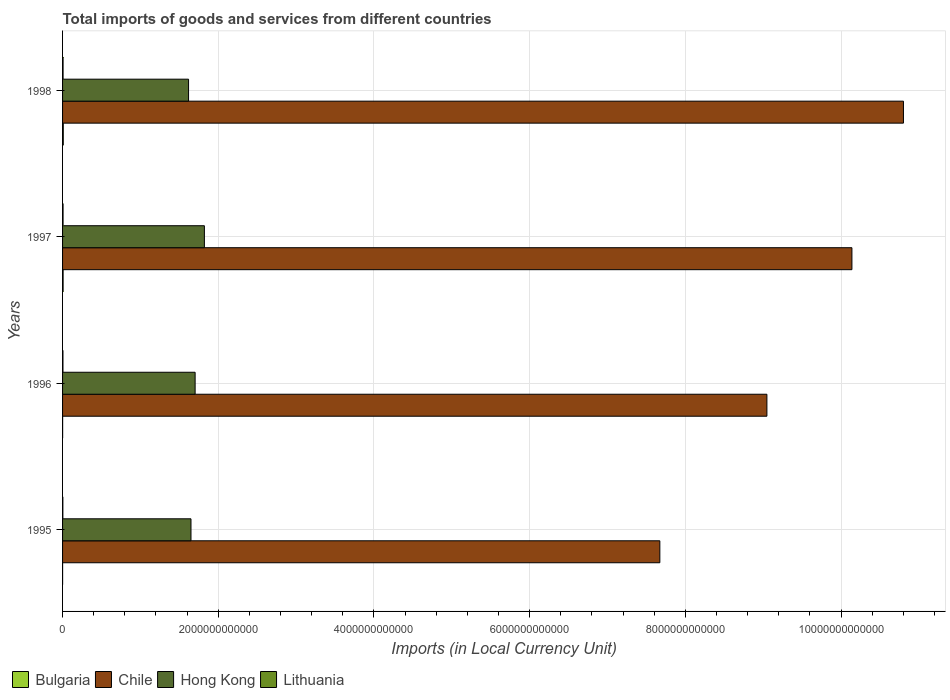How many groups of bars are there?
Offer a terse response. 4. Are the number of bars on each tick of the Y-axis equal?
Your response must be concise. Yes. What is the label of the 1st group of bars from the top?
Your answer should be very brief. 1998. What is the Amount of goods and services imports in Lithuania in 1997?
Offer a terse response. 6.45e+09. Across all years, what is the maximum Amount of goods and services imports in Lithuania?
Ensure brevity in your answer.  6.58e+09. Across all years, what is the minimum Amount of goods and services imports in Chile?
Ensure brevity in your answer.  7.67e+12. In which year was the Amount of goods and services imports in Bulgaria minimum?
Provide a succinct answer. 1995. What is the total Amount of goods and services imports in Lithuania in the graph?
Provide a succinct answer. 2.17e+1. What is the difference between the Amount of goods and services imports in Lithuania in 1995 and that in 1998?
Give a very brief answer. -2.87e+09. What is the difference between the Amount of goods and services imports in Bulgaria in 1997 and the Amount of goods and services imports in Hong Kong in 1998?
Offer a very short reply. -1.61e+12. What is the average Amount of goods and services imports in Hong Kong per year?
Make the answer very short. 1.70e+12. In the year 1997, what is the difference between the Amount of goods and services imports in Bulgaria and Amount of goods and services imports in Lithuania?
Keep it short and to the point. 5.67e+08. What is the ratio of the Amount of goods and services imports in Chile in 1995 to that in 1996?
Provide a short and direct response. 0.85. Is the Amount of goods and services imports in Chile in 1995 less than that in 1998?
Offer a terse response. Yes. What is the difference between the highest and the second highest Amount of goods and services imports in Hong Kong?
Provide a succinct answer. 1.19e+11. What is the difference between the highest and the lowest Amount of goods and services imports in Chile?
Your answer should be compact. 3.13e+12. In how many years, is the Amount of goods and services imports in Chile greater than the average Amount of goods and services imports in Chile taken over all years?
Ensure brevity in your answer.  2. What does the 3rd bar from the bottom in 1995 represents?
Make the answer very short. Hong Kong. Is it the case that in every year, the sum of the Amount of goods and services imports in Chile and Amount of goods and services imports in Bulgaria is greater than the Amount of goods and services imports in Lithuania?
Your response must be concise. Yes. How many bars are there?
Offer a terse response. 16. Are all the bars in the graph horizontal?
Make the answer very short. Yes. What is the difference between two consecutive major ticks on the X-axis?
Offer a terse response. 2.00e+12. Does the graph contain grids?
Ensure brevity in your answer.  Yes. How many legend labels are there?
Ensure brevity in your answer.  4. How are the legend labels stacked?
Make the answer very short. Horizontal. What is the title of the graph?
Give a very brief answer. Total imports of goods and services from different countries. Does "Turks and Caicos Islands" appear as one of the legend labels in the graph?
Your response must be concise. No. What is the label or title of the X-axis?
Provide a short and direct response. Imports (in Local Currency Unit). What is the label or title of the Y-axis?
Offer a terse response. Years. What is the Imports (in Local Currency Unit) of Bulgaria in 1995?
Your answer should be compact. 4.38e+08. What is the Imports (in Local Currency Unit) of Chile in 1995?
Your response must be concise. 7.67e+12. What is the Imports (in Local Currency Unit) of Hong Kong in 1995?
Your response must be concise. 1.65e+12. What is the Imports (in Local Currency Unit) in Lithuania in 1995?
Ensure brevity in your answer.  3.71e+09. What is the Imports (in Local Currency Unit) in Bulgaria in 1996?
Make the answer very short. 8.16e+08. What is the Imports (in Local Currency Unit) of Chile in 1996?
Provide a succinct answer. 9.05e+12. What is the Imports (in Local Currency Unit) of Hong Kong in 1996?
Your answer should be compact. 1.70e+12. What is the Imports (in Local Currency Unit) of Lithuania in 1996?
Provide a succinct answer. 4.98e+09. What is the Imports (in Local Currency Unit) of Bulgaria in 1997?
Ensure brevity in your answer.  7.02e+09. What is the Imports (in Local Currency Unit) of Chile in 1997?
Offer a very short reply. 1.01e+13. What is the Imports (in Local Currency Unit) in Hong Kong in 1997?
Keep it short and to the point. 1.82e+12. What is the Imports (in Local Currency Unit) in Lithuania in 1997?
Keep it short and to the point. 6.45e+09. What is the Imports (in Local Currency Unit) of Bulgaria in 1998?
Ensure brevity in your answer.  9.29e+09. What is the Imports (in Local Currency Unit) of Chile in 1998?
Your response must be concise. 1.08e+13. What is the Imports (in Local Currency Unit) of Hong Kong in 1998?
Your answer should be compact. 1.62e+12. What is the Imports (in Local Currency Unit) of Lithuania in 1998?
Offer a terse response. 6.58e+09. Across all years, what is the maximum Imports (in Local Currency Unit) in Bulgaria?
Your answer should be very brief. 9.29e+09. Across all years, what is the maximum Imports (in Local Currency Unit) in Chile?
Offer a very short reply. 1.08e+13. Across all years, what is the maximum Imports (in Local Currency Unit) of Hong Kong?
Ensure brevity in your answer.  1.82e+12. Across all years, what is the maximum Imports (in Local Currency Unit) of Lithuania?
Keep it short and to the point. 6.58e+09. Across all years, what is the minimum Imports (in Local Currency Unit) of Bulgaria?
Provide a short and direct response. 4.38e+08. Across all years, what is the minimum Imports (in Local Currency Unit) in Chile?
Offer a very short reply. 7.67e+12. Across all years, what is the minimum Imports (in Local Currency Unit) of Hong Kong?
Give a very brief answer. 1.62e+12. Across all years, what is the minimum Imports (in Local Currency Unit) in Lithuania?
Provide a succinct answer. 3.71e+09. What is the total Imports (in Local Currency Unit) in Bulgaria in the graph?
Provide a succinct answer. 1.76e+1. What is the total Imports (in Local Currency Unit) in Chile in the graph?
Your answer should be compact. 3.77e+13. What is the total Imports (in Local Currency Unit) of Hong Kong in the graph?
Your answer should be very brief. 6.79e+12. What is the total Imports (in Local Currency Unit) in Lithuania in the graph?
Keep it short and to the point. 2.17e+1. What is the difference between the Imports (in Local Currency Unit) of Bulgaria in 1995 and that in 1996?
Your answer should be compact. -3.78e+08. What is the difference between the Imports (in Local Currency Unit) of Chile in 1995 and that in 1996?
Provide a short and direct response. -1.38e+12. What is the difference between the Imports (in Local Currency Unit) in Hong Kong in 1995 and that in 1996?
Your answer should be compact. -5.33e+1. What is the difference between the Imports (in Local Currency Unit) of Lithuania in 1995 and that in 1996?
Give a very brief answer. -1.27e+09. What is the difference between the Imports (in Local Currency Unit) in Bulgaria in 1995 and that in 1997?
Provide a succinct answer. -6.58e+09. What is the difference between the Imports (in Local Currency Unit) of Chile in 1995 and that in 1997?
Your answer should be compact. -2.47e+12. What is the difference between the Imports (in Local Currency Unit) in Hong Kong in 1995 and that in 1997?
Provide a succinct answer. -1.72e+11. What is the difference between the Imports (in Local Currency Unit) in Lithuania in 1995 and that in 1997?
Ensure brevity in your answer.  -2.74e+09. What is the difference between the Imports (in Local Currency Unit) of Bulgaria in 1995 and that in 1998?
Keep it short and to the point. -8.85e+09. What is the difference between the Imports (in Local Currency Unit) of Chile in 1995 and that in 1998?
Offer a terse response. -3.13e+12. What is the difference between the Imports (in Local Currency Unit) of Hong Kong in 1995 and that in 1998?
Provide a succinct answer. 3.11e+1. What is the difference between the Imports (in Local Currency Unit) in Lithuania in 1995 and that in 1998?
Offer a terse response. -2.87e+09. What is the difference between the Imports (in Local Currency Unit) in Bulgaria in 1996 and that in 1997?
Keep it short and to the point. -6.20e+09. What is the difference between the Imports (in Local Currency Unit) of Chile in 1996 and that in 1997?
Offer a very short reply. -1.09e+12. What is the difference between the Imports (in Local Currency Unit) in Hong Kong in 1996 and that in 1997?
Your answer should be compact. -1.19e+11. What is the difference between the Imports (in Local Currency Unit) of Lithuania in 1996 and that in 1997?
Give a very brief answer. -1.48e+09. What is the difference between the Imports (in Local Currency Unit) in Bulgaria in 1996 and that in 1998?
Offer a terse response. -8.47e+09. What is the difference between the Imports (in Local Currency Unit) of Chile in 1996 and that in 1998?
Provide a short and direct response. -1.75e+12. What is the difference between the Imports (in Local Currency Unit) in Hong Kong in 1996 and that in 1998?
Keep it short and to the point. 8.44e+1. What is the difference between the Imports (in Local Currency Unit) of Lithuania in 1996 and that in 1998?
Keep it short and to the point. -1.60e+09. What is the difference between the Imports (in Local Currency Unit) in Bulgaria in 1997 and that in 1998?
Your answer should be compact. -2.27e+09. What is the difference between the Imports (in Local Currency Unit) of Chile in 1997 and that in 1998?
Provide a short and direct response. -6.62e+11. What is the difference between the Imports (in Local Currency Unit) of Hong Kong in 1997 and that in 1998?
Offer a terse response. 2.03e+11. What is the difference between the Imports (in Local Currency Unit) of Lithuania in 1997 and that in 1998?
Your answer should be very brief. -1.26e+08. What is the difference between the Imports (in Local Currency Unit) of Bulgaria in 1995 and the Imports (in Local Currency Unit) of Chile in 1996?
Offer a very short reply. -9.05e+12. What is the difference between the Imports (in Local Currency Unit) of Bulgaria in 1995 and the Imports (in Local Currency Unit) of Hong Kong in 1996?
Offer a terse response. -1.70e+12. What is the difference between the Imports (in Local Currency Unit) of Bulgaria in 1995 and the Imports (in Local Currency Unit) of Lithuania in 1996?
Your response must be concise. -4.54e+09. What is the difference between the Imports (in Local Currency Unit) in Chile in 1995 and the Imports (in Local Currency Unit) in Hong Kong in 1996?
Offer a very short reply. 5.97e+12. What is the difference between the Imports (in Local Currency Unit) of Chile in 1995 and the Imports (in Local Currency Unit) of Lithuania in 1996?
Provide a succinct answer. 7.67e+12. What is the difference between the Imports (in Local Currency Unit) of Hong Kong in 1995 and the Imports (in Local Currency Unit) of Lithuania in 1996?
Keep it short and to the point. 1.64e+12. What is the difference between the Imports (in Local Currency Unit) of Bulgaria in 1995 and the Imports (in Local Currency Unit) of Chile in 1997?
Keep it short and to the point. -1.01e+13. What is the difference between the Imports (in Local Currency Unit) in Bulgaria in 1995 and the Imports (in Local Currency Unit) in Hong Kong in 1997?
Your answer should be very brief. -1.82e+12. What is the difference between the Imports (in Local Currency Unit) in Bulgaria in 1995 and the Imports (in Local Currency Unit) in Lithuania in 1997?
Provide a short and direct response. -6.02e+09. What is the difference between the Imports (in Local Currency Unit) of Chile in 1995 and the Imports (in Local Currency Unit) of Hong Kong in 1997?
Provide a succinct answer. 5.85e+12. What is the difference between the Imports (in Local Currency Unit) of Chile in 1995 and the Imports (in Local Currency Unit) of Lithuania in 1997?
Ensure brevity in your answer.  7.67e+12. What is the difference between the Imports (in Local Currency Unit) in Hong Kong in 1995 and the Imports (in Local Currency Unit) in Lithuania in 1997?
Offer a very short reply. 1.64e+12. What is the difference between the Imports (in Local Currency Unit) in Bulgaria in 1995 and the Imports (in Local Currency Unit) in Chile in 1998?
Provide a succinct answer. -1.08e+13. What is the difference between the Imports (in Local Currency Unit) in Bulgaria in 1995 and the Imports (in Local Currency Unit) in Hong Kong in 1998?
Make the answer very short. -1.62e+12. What is the difference between the Imports (in Local Currency Unit) of Bulgaria in 1995 and the Imports (in Local Currency Unit) of Lithuania in 1998?
Make the answer very short. -6.14e+09. What is the difference between the Imports (in Local Currency Unit) in Chile in 1995 and the Imports (in Local Currency Unit) in Hong Kong in 1998?
Make the answer very short. 6.05e+12. What is the difference between the Imports (in Local Currency Unit) of Chile in 1995 and the Imports (in Local Currency Unit) of Lithuania in 1998?
Your answer should be compact. 7.67e+12. What is the difference between the Imports (in Local Currency Unit) of Hong Kong in 1995 and the Imports (in Local Currency Unit) of Lithuania in 1998?
Ensure brevity in your answer.  1.64e+12. What is the difference between the Imports (in Local Currency Unit) in Bulgaria in 1996 and the Imports (in Local Currency Unit) in Chile in 1997?
Your answer should be very brief. -1.01e+13. What is the difference between the Imports (in Local Currency Unit) in Bulgaria in 1996 and the Imports (in Local Currency Unit) in Hong Kong in 1997?
Ensure brevity in your answer.  -1.82e+12. What is the difference between the Imports (in Local Currency Unit) in Bulgaria in 1996 and the Imports (in Local Currency Unit) in Lithuania in 1997?
Offer a terse response. -5.64e+09. What is the difference between the Imports (in Local Currency Unit) in Chile in 1996 and the Imports (in Local Currency Unit) in Hong Kong in 1997?
Your answer should be very brief. 7.23e+12. What is the difference between the Imports (in Local Currency Unit) in Chile in 1996 and the Imports (in Local Currency Unit) in Lithuania in 1997?
Give a very brief answer. 9.04e+12. What is the difference between the Imports (in Local Currency Unit) of Hong Kong in 1996 and the Imports (in Local Currency Unit) of Lithuania in 1997?
Ensure brevity in your answer.  1.70e+12. What is the difference between the Imports (in Local Currency Unit) in Bulgaria in 1996 and the Imports (in Local Currency Unit) in Chile in 1998?
Give a very brief answer. -1.08e+13. What is the difference between the Imports (in Local Currency Unit) in Bulgaria in 1996 and the Imports (in Local Currency Unit) in Hong Kong in 1998?
Your answer should be compact. -1.62e+12. What is the difference between the Imports (in Local Currency Unit) of Bulgaria in 1996 and the Imports (in Local Currency Unit) of Lithuania in 1998?
Provide a succinct answer. -5.76e+09. What is the difference between the Imports (in Local Currency Unit) in Chile in 1996 and the Imports (in Local Currency Unit) in Hong Kong in 1998?
Ensure brevity in your answer.  7.43e+12. What is the difference between the Imports (in Local Currency Unit) of Chile in 1996 and the Imports (in Local Currency Unit) of Lithuania in 1998?
Offer a very short reply. 9.04e+12. What is the difference between the Imports (in Local Currency Unit) in Hong Kong in 1996 and the Imports (in Local Currency Unit) in Lithuania in 1998?
Offer a terse response. 1.70e+12. What is the difference between the Imports (in Local Currency Unit) of Bulgaria in 1997 and the Imports (in Local Currency Unit) of Chile in 1998?
Ensure brevity in your answer.  -1.08e+13. What is the difference between the Imports (in Local Currency Unit) in Bulgaria in 1997 and the Imports (in Local Currency Unit) in Hong Kong in 1998?
Your answer should be compact. -1.61e+12. What is the difference between the Imports (in Local Currency Unit) of Bulgaria in 1997 and the Imports (in Local Currency Unit) of Lithuania in 1998?
Keep it short and to the point. 4.41e+08. What is the difference between the Imports (in Local Currency Unit) of Chile in 1997 and the Imports (in Local Currency Unit) of Hong Kong in 1998?
Ensure brevity in your answer.  8.52e+12. What is the difference between the Imports (in Local Currency Unit) of Chile in 1997 and the Imports (in Local Currency Unit) of Lithuania in 1998?
Ensure brevity in your answer.  1.01e+13. What is the difference between the Imports (in Local Currency Unit) of Hong Kong in 1997 and the Imports (in Local Currency Unit) of Lithuania in 1998?
Ensure brevity in your answer.  1.82e+12. What is the average Imports (in Local Currency Unit) of Bulgaria per year?
Your answer should be compact. 4.39e+09. What is the average Imports (in Local Currency Unit) of Chile per year?
Provide a short and direct response. 9.42e+12. What is the average Imports (in Local Currency Unit) in Hong Kong per year?
Provide a short and direct response. 1.70e+12. What is the average Imports (in Local Currency Unit) in Lithuania per year?
Offer a terse response. 5.43e+09. In the year 1995, what is the difference between the Imports (in Local Currency Unit) of Bulgaria and Imports (in Local Currency Unit) of Chile?
Keep it short and to the point. -7.67e+12. In the year 1995, what is the difference between the Imports (in Local Currency Unit) of Bulgaria and Imports (in Local Currency Unit) of Hong Kong?
Provide a succinct answer. -1.65e+12. In the year 1995, what is the difference between the Imports (in Local Currency Unit) of Bulgaria and Imports (in Local Currency Unit) of Lithuania?
Your answer should be compact. -3.27e+09. In the year 1995, what is the difference between the Imports (in Local Currency Unit) of Chile and Imports (in Local Currency Unit) of Hong Kong?
Make the answer very short. 6.02e+12. In the year 1995, what is the difference between the Imports (in Local Currency Unit) in Chile and Imports (in Local Currency Unit) in Lithuania?
Give a very brief answer. 7.67e+12. In the year 1995, what is the difference between the Imports (in Local Currency Unit) of Hong Kong and Imports (in Local Currency Unit) of Lithuania?
Keep it short and to the point. 1.65e+12. In the year 1996, what is the difference between the Imports (in Local Currency Unit) in Bulgaria and Imports (in Local Currency Unit) in Chile?
Make the answer very short. -9.05e+12. In the year 1996, what is the difference between the Imports (in Local Currency Unit) of Bulgaria and Imports (in Local Currency Unit) of Hong Kong?
Your answer should be compact. -1.70e+12. In the year 1996, what is the difference between the Imports (in Local Currency Unit) of Bulgaria and Imports (in Local Currency Unit) of Lithuania?
Provide a succinct answer. -4.16e+09. In the year 1996, what is the difference between the Imports (in Local Currency Unit) of Chile and Imports (in Local Currency Unit) of Hong Kong?
Offer a very short reply. 7.35e+12. In the year 1996, what is the difference between the Imports (in Local Currency Unit) in Chile and Imports (in Local Currency Unit) in Lithuania?
Offer a terse response. 9.04e+12. In the year 1996, what is the difference between the Imports (in Local Currency Unit) in Hong Kong and Imports (in Local Currency Unit) in Lithuania?
Provide a succinct answer. 1.70e+12. In the year 1997, what is the difference between the Imports (in Local Currency Unit) of Bulgaria and Imports (in Local Currency Unit) of Chile?
Give a very brief answer. -1.01e+13. In the year 1997, what is the difference between the Imports (in Local Currency Unit) in Bulgaria and Imports (in Local Currency Unit) in Hong Kong?
Ensure brevity in your answer.  -1.81e+12. In the year 1997, what is the difference between the Imports (in Local Currency Unit) of Bulgaria and Imports (in Local Currency Unit) of Lithuania?
Provide a succinct answer. 5.67e+08. In the year 1997, what is the difference between the Imports (in Local Currency Unit) of Chile and Imports (in Local Currency Unit) of Hong Kong?
Provide a short and direct response. 8.32e+12. In the year 1997, what is the difference between the Imports (in Local Currency Unit) of Chile and Imports (in Local Currency Unit) of Lithuania?
Offer a very short reply. 1.01e+13. In the year 1997, what is the difference between the Imports (in Local Currency Unit) in Hong Kong and Imports (in Local Currency Unit) in Lithuania?
Keep it short and to the point. 1.82e+12. In the year 1998, what is the difference between the Imports (in Local Currency Unit) of Bulgaria and Imports (in Local Currency Unit) of Chile?
Your answer should be very brief. -1.08e+13. In the year 1998, what is the difference between the Imports (in Local Currency Unit) of Bulgaria and Imports (in Local Currency Unit) of Hong Kong?
Offer a terse response. -1.61e+12. In the year 1998, what is the difference between the Imports (in Local Currency Unit) of Bulgaria and Imports (in Local Currency Unit) of Lithuania?
Give a very brief answer. 2.71e+09. In the year 1998, what is the difference between the Imports (in Local Currency Unit) in Chile and Imports (in Local Currency Unit) in Hong Kong?
Make the answer very short. 9.18e+12. In the year 1998, what is the difference between the Imports (in Local Currency Unit) in Chile and Imports (in Local Currency Unit) in Lithuania?
Your answer should be very brief. 1.08e+13. In the year 1998, what is the difference between the Imports (in Local Currency Unit) of Hong Kong and Imports (in Local Currency Unit) of Lithuania?
Provide a succinct answer. 1.61e+12. What is the ratio of the Imports (in Local Currency Unit) in Bulgaria in 1995 to that in 1996?
Offer a terse response. 0.54. What is the ratio of the Imports (in Local Currency Unit) in Chile in 1995 to that in 1996?
Provide a succinct answer. 0.85. What is the ratio of the Imports (in Local Currency Unit) in Hong Kong in 1995 to that in 1996?
Give a very brief answer. 0.97. What is the ratio of the Imports (in Local Currency Unit) of Lithuania in 1995 to that in 1996?
Give a very brief answer. 0.75. What is the ratio of the Imports (in Local Currency Unit) of Bulgaria in 1995 to that in 1997?
Your answer should be compact. 0.06. What is the ratio of the Imports (in Local Currency Unit) in Chile in 1995 to that in 1997?
Offer a very short reply. 0.76. What is the ratio of the Imports (in Local Currency Unit) in Hong Kong in 1995 to that in 1997?
Give a very brief answer. 0.91. What is the ratio of the Imports (in Local Currency Unit) of Lithuania in 1995 to that in 1997?
Ensure brevity in your answer.  0.57. What is the ratio of the Imports (in Local Currency Unit) in Bulgaria in 1995 to that in 1998?
Offer a terse response. 0.05. What is the ratio of the Imports (in Local Currency Unit) of Chile in 1995 to that in 1998?
Your answer should be very brief. 0.71. What is the ratio of the Imports (in Local Currency Unit) in Hong Kong in 1995 to that in 1998?
Keep it short and to the point. 1.02. What is the ratio of the Imports (in Local Currency Unit) in Lithuania in 1995 to that in 1998?
Ensure brevity in your answer.  0.56. What is the ratio of the Imports (in Local Currency Unit) in Bulgaria in 1996 to that in 1997?
Your answer should be very brief. 0.12. What is the ratio of the Imports (in Local Currency Unit) of Chile in 1996 to that in 1997?
Offer a terse response. 0.89. What is the ratio of the Imports (in Local Currency Unit) in Hong Kong in 1996 to that in 1997?
Provide a short and direct response. 0.93. What is the ratio of the Imports (in Local Currency Unit) in Lithuania in 1996 to that in 1997?
Keep it short and to the point. 0.77. What is the ratio of the Imports (in Local Currency Unit) in Bulgaria in 1996 to that in 1998?
Give a very brief answer. 0.09. What is the ratio of the Imports (in Local Currency Unit) in Chile in 1996 to that in 1998?
Offer a very short reply. 0.84. What is the ratio of the Imports (in Local Currency Unit) of Hong Kong in 1996 to that in 1998?
Make the answer very short. 1.05. What is the ratio of the Imports (in Local Currency Unit) of Lithuania in 1996 to that in 1998?
Offer a terse response. 0.76. What is the ratio of the Imports (in Local Currency Unit) in Bulgaria in 1997 to that in 1998?
Keep it short and to the point. 0.76. What is the ratio of the Imports (in Local Currency Unit) of Chile in 1997 to that in 1998?
Your answer should be compact. 0.94. What is the ratio of the Imports (in Local Currency Unit) of Hong Kong in 1997 to that in 1998?
Your response must be concise. 1.13. What is the ratio of the Imports (in Local Currency Unit) in Lithuania in 1997 to that in 1998?
Offer a very short reply. 0.98. What is the difference between the highest and the second highest Imports (in Local Currency Unit) in Bulgaria?
Give a very brief answer. 2.27e+09. What is the difference between the highest and the second highest Imports (in Local Currency Unit) of Chile?
Make the answer very short. 6.62e+11. What is the difference between the highest and the second highest Imports (in Local Currency Unit) in Hong Kong?
Give a very brief answer. 1.19e+11. What is the difference between the highest and the second highest Imports (in Local Currency Unit) in Lithuania?
Offer a terse response. 1.26e+08. What is the difference between the highest and the lowest Imports (in Local Currency Unit) in Bulgaria?
Keep it short and to the point. 8.85e+09. What is the difference between the highest and the lowest Imports (in Local Currency Unit) of Chile?
Your answer should be compact. 3.13e+12. What is the difference between the highest and the lowest Imports (in Local Currency Unit) in Hong Kong?
Provide a succinct answer. 2.03e+11. What is the difference between the highest and the lowest Imports (in Local Currency Unit) in Lithuania?
Provide a succinct answer. 2.87e+09. 